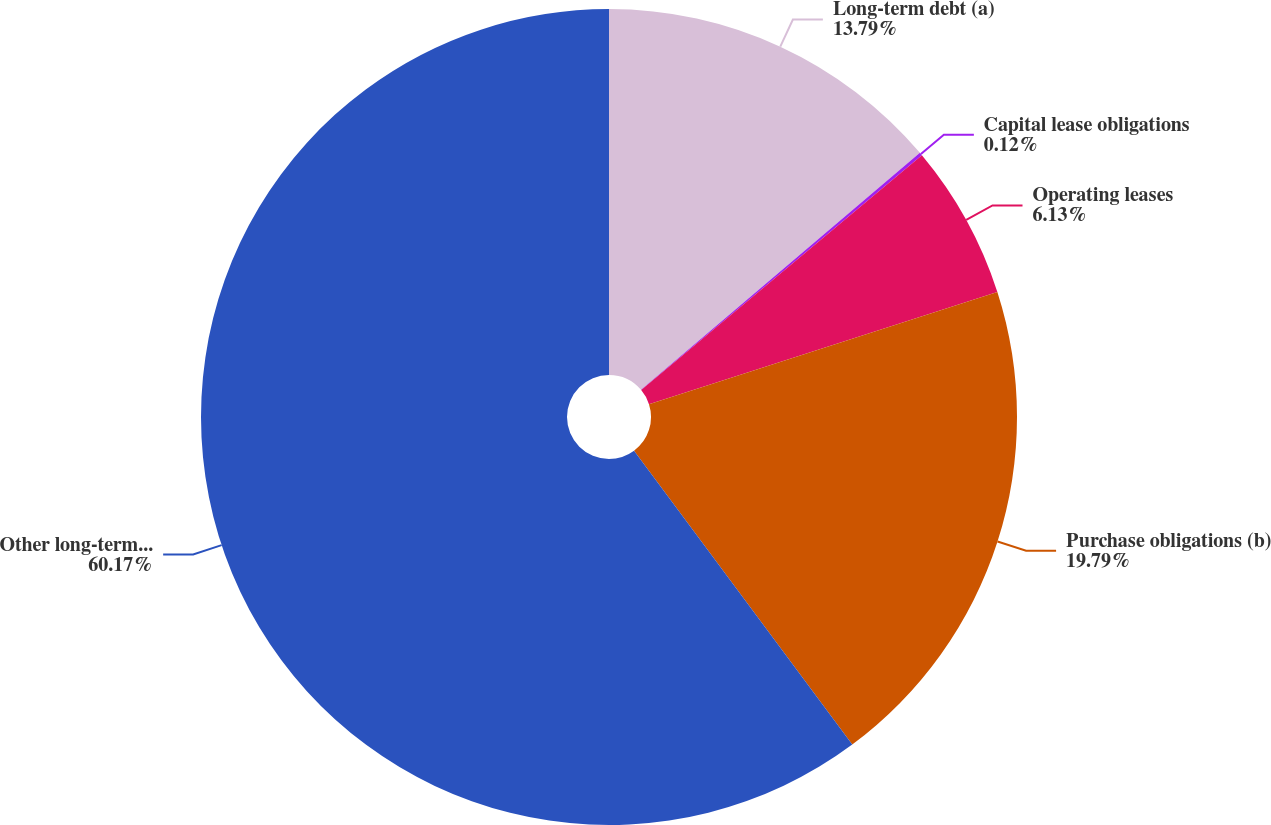Convert chart. <chart><loc_0><loc_0><loc_500><loc_500><pie_chart><fcel>Long-term debt (a)<fcel>Capital lease obligations<fcel>Operating leases<fcel>Purchase obligations (b)<fcel>Other long-term liabilities<nl><fcel>13.79%<fcel>0.12%<fcel>6.13%<fcel>19.79%<fcel>60.16%<nl></chart> 